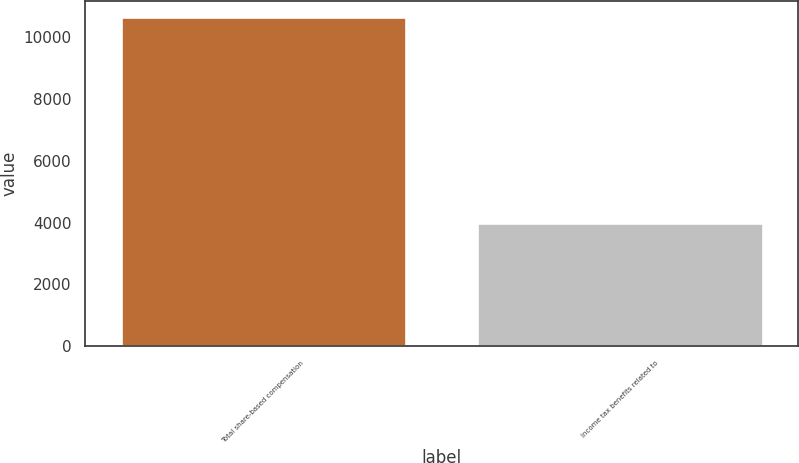Convert chart. <chart><loc_0><loc_0><loc_500><loc_500><bar_chart><fcel>Total share-based compensation<fcel>Income tax benefits related to<nl><fcel>10621<fcel>3988<nl></chart> 